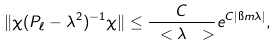<formula> <loc_0><loc_0><loc_500><loc_500>\| \chi ( P _ { \ell } - \lambda ^ { 2 } ) ^ { - 1 } \chi \| \leq \frac { C } { \ < \lambda \ > } e ^ { C | \i m \lambda | } ,</formula> 